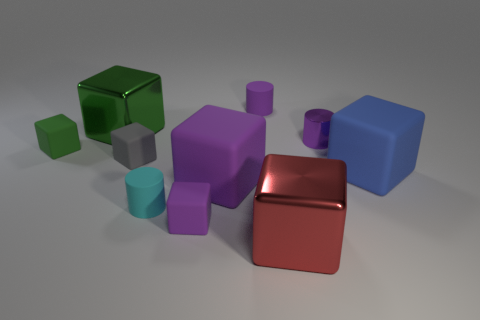What is the tiny gray thing made of?
Make the answer very short. Rubber. Are there any gray objects on the left side of the large green cube?
Offer a terse response. No. How many small purple objects are in front of the tiny purple matte thing in front of the large purple matte thing?
Offer a very short reply. 0. There is a purple block that is the same size as the purple metallic object; what is it made of?
Your response must be concise. Rubber. What number of other objects are there of the same material as the blue object?
Give a very brief answer. 6. How many purple metal objects are in front of the big blue object?
Keep it short and to the point. 0. What number of spheres are either tiny shiny things or large red objects?
Your response must be concise. 0. What size is the matte object that is behind the gray block and to the right of the tiny green object?
Keep it short and to the point. Small. How many other objects are the same color as the metal cylinder?
Offer a terse response. 3. Do the tiny cyan object and the block that is on the right side of the big red thing have the same material?
Make the answer very short. Yes. 